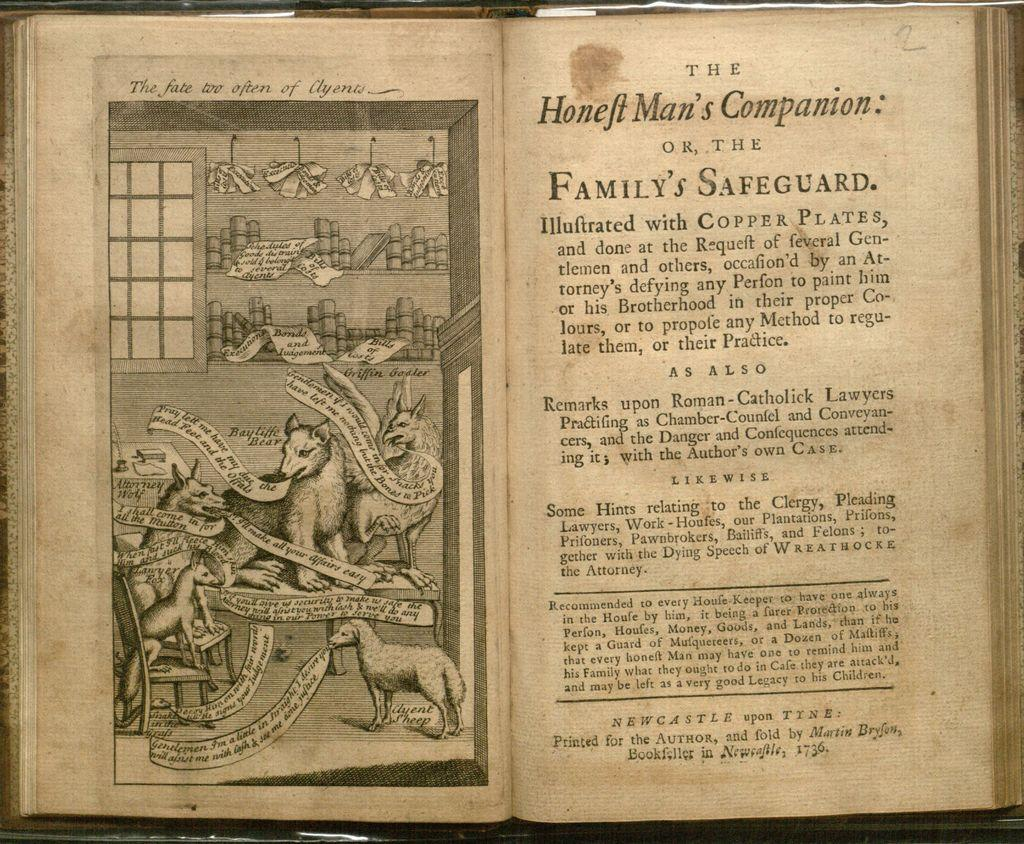Provide a one-sentence caption for the provided image. Black and white book opened to Honeft man's Companion. 